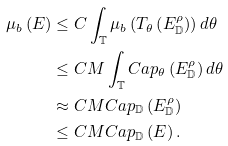Convert formula to latex. <formula><loc_0><loc_0><loc_500><loc_500>\mu _ { b } \left ( E \right ) & \leq C \int _ { \mathbb { T } } \mu _ { b } \left ( T _ { \theta } \left ( E _ { \mathbb { D } } ^ { \rho } \right ) \right ) d \theta \\ & \leq C M \int _ { \mathbb { T } } C a p _ { \theta } \left ( E _ { \mathbb { D } } ^ { \rho } \right ) d \theta \\ & \approx C M C a p _ { \mathbb { D } } \left ( E _ { \mathbb { D } } ^ { \rho } \right ) \\ & \leq C M C a p _ { \mathbb { D } } \left ( E \right ) .</formula> 